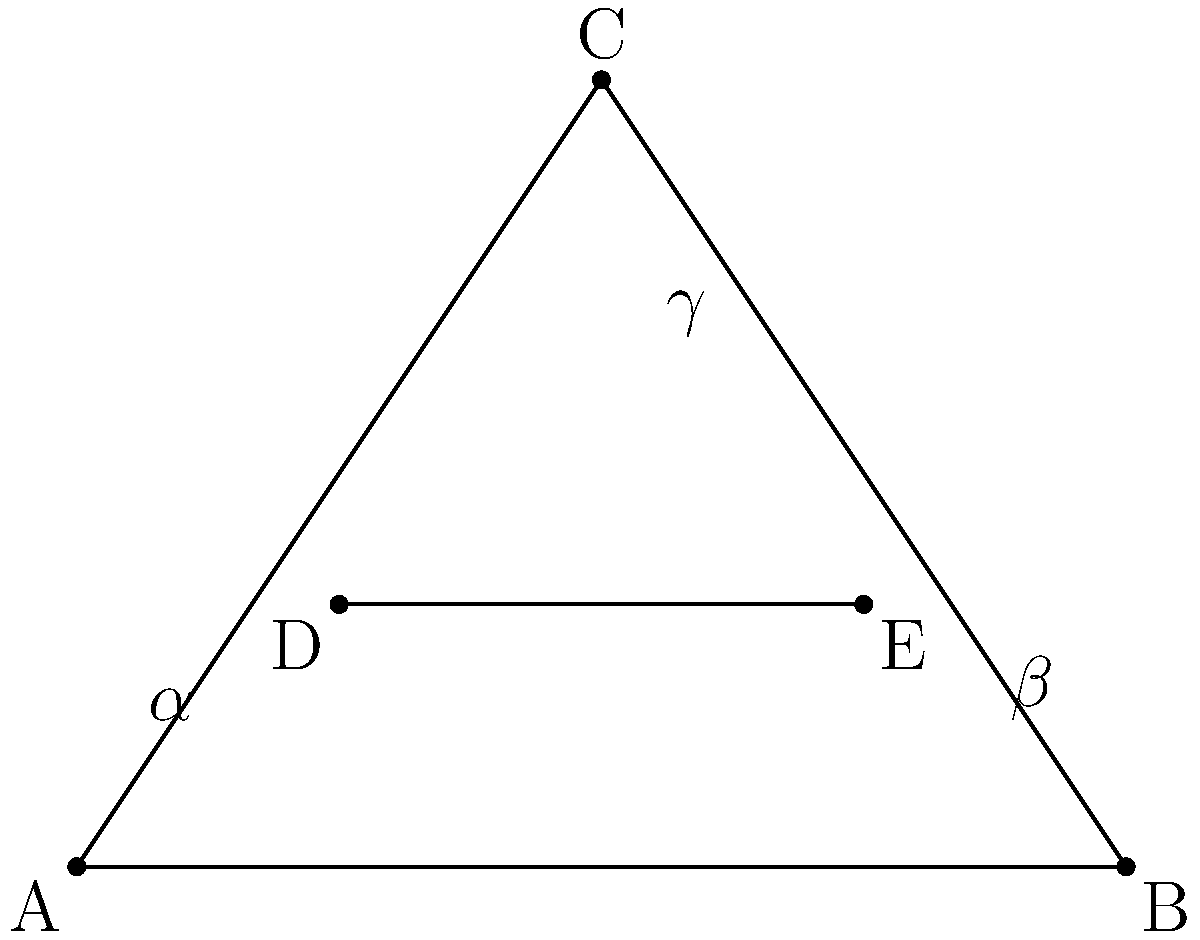On a tactical board representing Indy Eleven's formation, players A, B, and C form a triangle, while players D and E are positioned on a line intersecting this triangle. If $\alpha + \beta + \gamma = 180°$ and the line DE is parallel to AB, what is the value of $\gamma$ in degrees? Let's approach this step-by-step:

1) In any triangle, the sum of all interior angles is 180°. We're given that $\alpha + \beta + \gamma = 180°$, which confirms that A, B, and C form a triangle.

2) The line DE is parallel to AB. This is a key piece of information, as parallel lines create equal corresponding angles when intersected by another line.

3) In this case, the line AC intersects both AB and DE, creating corresponding angles. Therefore, the angle at D (between DC and DE) is equal to $\alpha$.

4) Similarly, the angle at E (between EC and ED) is equal to $\beta$.

5) Now, let's consider the triangle CDE. We know two of its angles: $\alpha$ at D and $\beta$ at E.

6) The sum of angles in a triangle is always 180°. So for triangle CDE:
   $\alpha + \beta + \gamma = 180°$

7) But this is the same equation we were given for triangle ABC!

8) This means that the angle $\gamma$ in triangle ABC is the same as the angle at C in triangle CDE.

Therefore, without knowing the specific values of $\alpha$ and $\beta$, we can conclude that $\gamma$ must be the same in both triangles, and it's the angle at vertex C.
Answer: $\gamma$ 